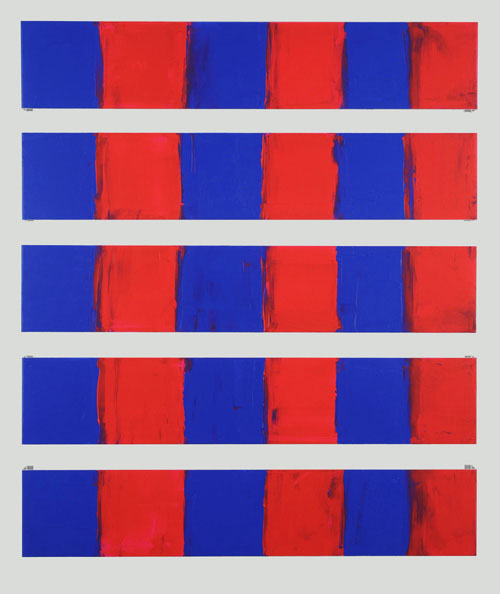Can you discuss the significance of the repeated pattern in this composition? The repetition of the rectangular panels in this abstract piece is significant as it creates a rhythmic pattern that can represent many aspects of human or natural rhythms. This could symbolize anything from the repetitive nature of daily life to the consistent waves of the ocean. It invites viewers to consider the impact of pattern in life and in art, possibly suggesting a meditative or reflective response to the regularity and predictability it presents. 